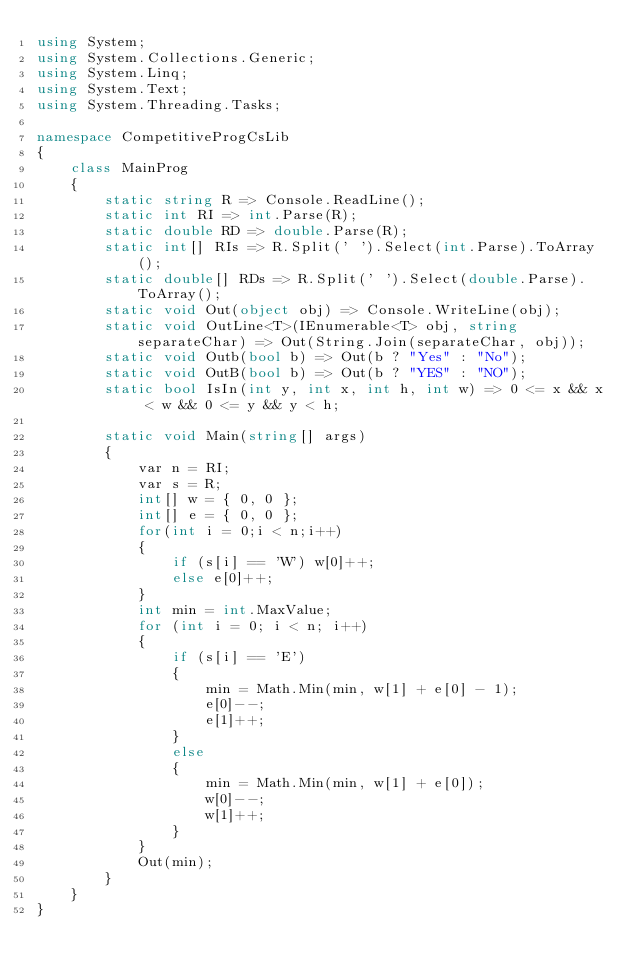<code> <loc_0><loc_0><loc_500><loc_500><_C#_>using System;
using System.Collections.Generic;
using System.Linq;
using System.Text;
using System.Threading.Tasks;

namespace CompetitiveProgCsLib
{
	class MainProg
	{
		static string R => Console.ReadLine();
		static int RI => int.Parse(R);
		static double RD => double.Parse(R);
		static int[] RIs => R.Split(' ').Select(int.Parse).ToArray();
		static double[] RDs => R.Split(' ').Select(double.Parse).ToArray();
		static void Out(object obj) => Console.WriteLine(obj);
		static void OutLine<T>(IEnumerable<T> obj, string separateChar) => Out(String.Join(separateChar, obj));
		static void Outb(bool b) => Out(b ? "Yes" : "No");
		static void OutB(bool b) => Out(b ? "YES" : "NO");
		static bool IsIn(int y, int x, int h, int w) => 0 <= x && x < w && 0 <= y && y < h;

		static void Main(string[] args)
		{
			var n = RI;
			var s = R;
			int[] w = { 0, 0 };
			int[] e = { 0, 0 };
			for(int i = 0;i < n;i++)
			{
				if (s[i] == 'W') w[0]++;
				else e[0]++;
			}
			int min = int.MaxValue;
			for (int i = 0; i < n; i++)
			{
				if (s[i] == 'E')
				{
					min = Math.Min(min, w[1] + e[0] - 1);
					e[0]--;
					e[1]++;
				}
				else
				{
					min = Math.Min(min, w[1] + e[0]);
					w[0]--;
					w[1]++;
				}
			}
			Out(min);
		}		
	}
}
</code> 